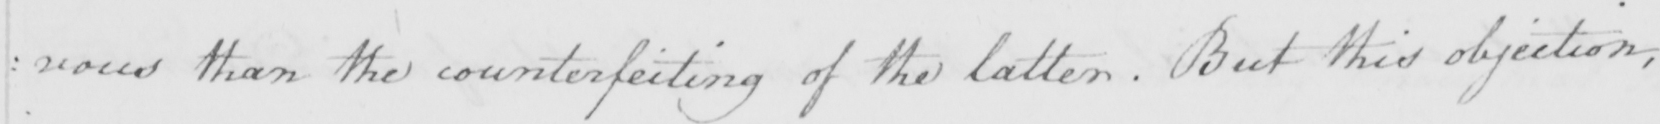Can you read and transcribe this handwriting? : vous than the counterfeiting of the latter . But this objection , 